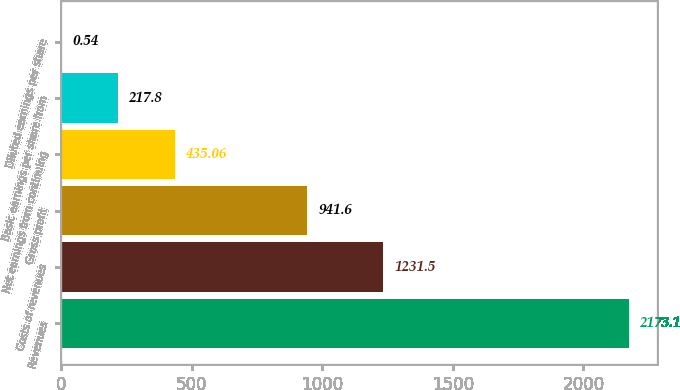Convert chart. <chart><loc_0><loc_0><loc_500><loc_500><bar_chart><fcel>Revenues<fcel>Costs of revenues<fcel>Gross profit<fcel>Net earnings from continuing<fcel>Basic earnings per share from<fcel>Diluted earnings per share<nl><fcel>2173.1<fcel>1231.5<fcel>941.6<fcel>435.06<fcel>217.8<fcel>0.54<nl></chart> 